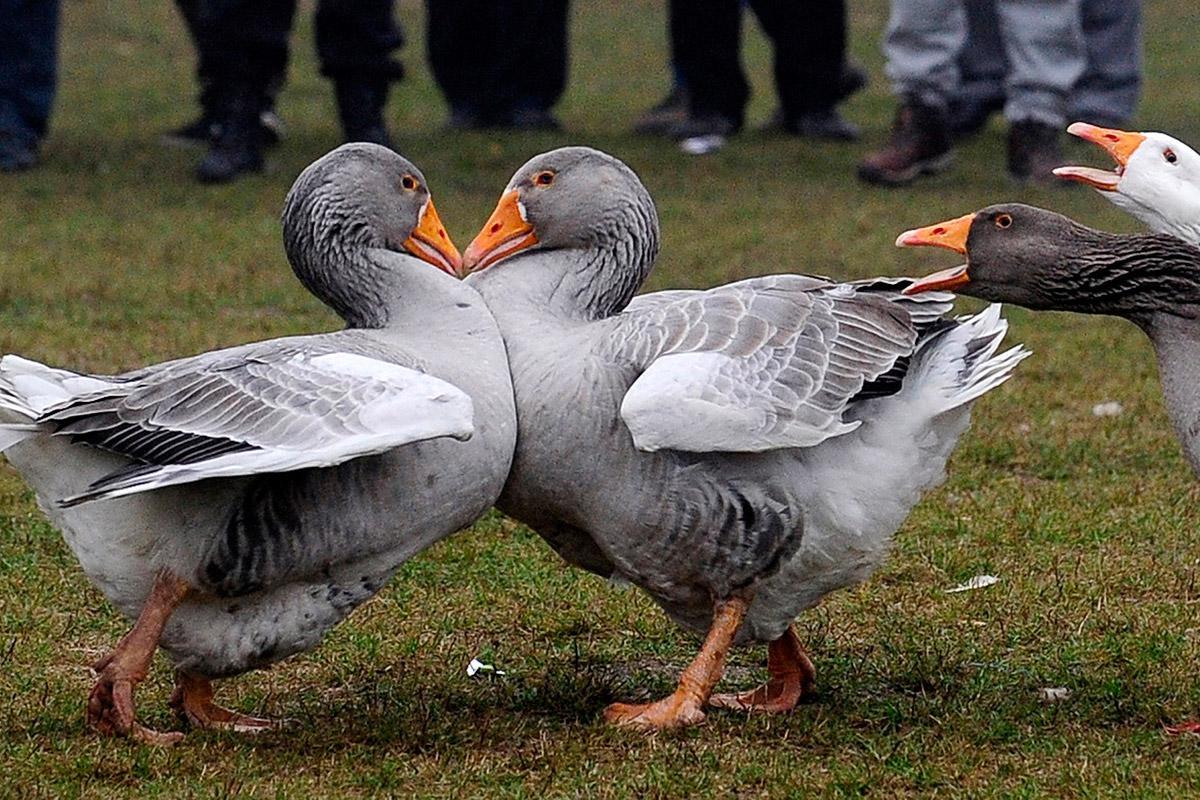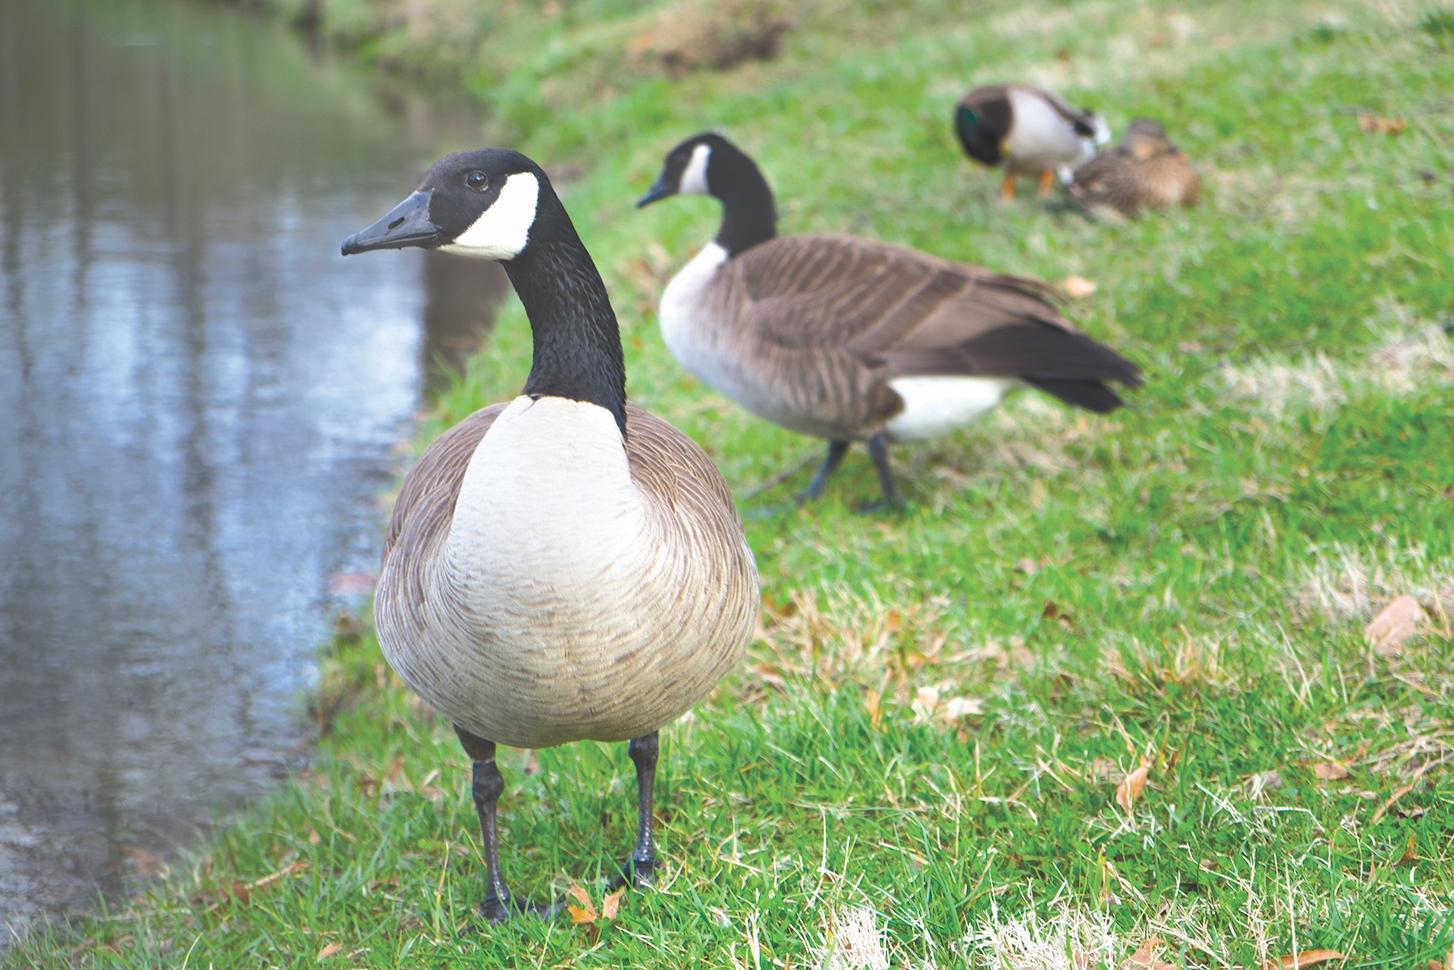The first image is the image on the left, the second image is the image on the right. Evaluate the accuracy of this statement regarding the images: "There are two geese with their beaks pressed together in one of the images.". Is it true? Answer yes or no. Yes. The first image is the image on the left, the second image is the image on the right. Assess this claim about the two images: "geese are facing each other and touching beaks". Correct or not? Answer yes or no. Yes. 